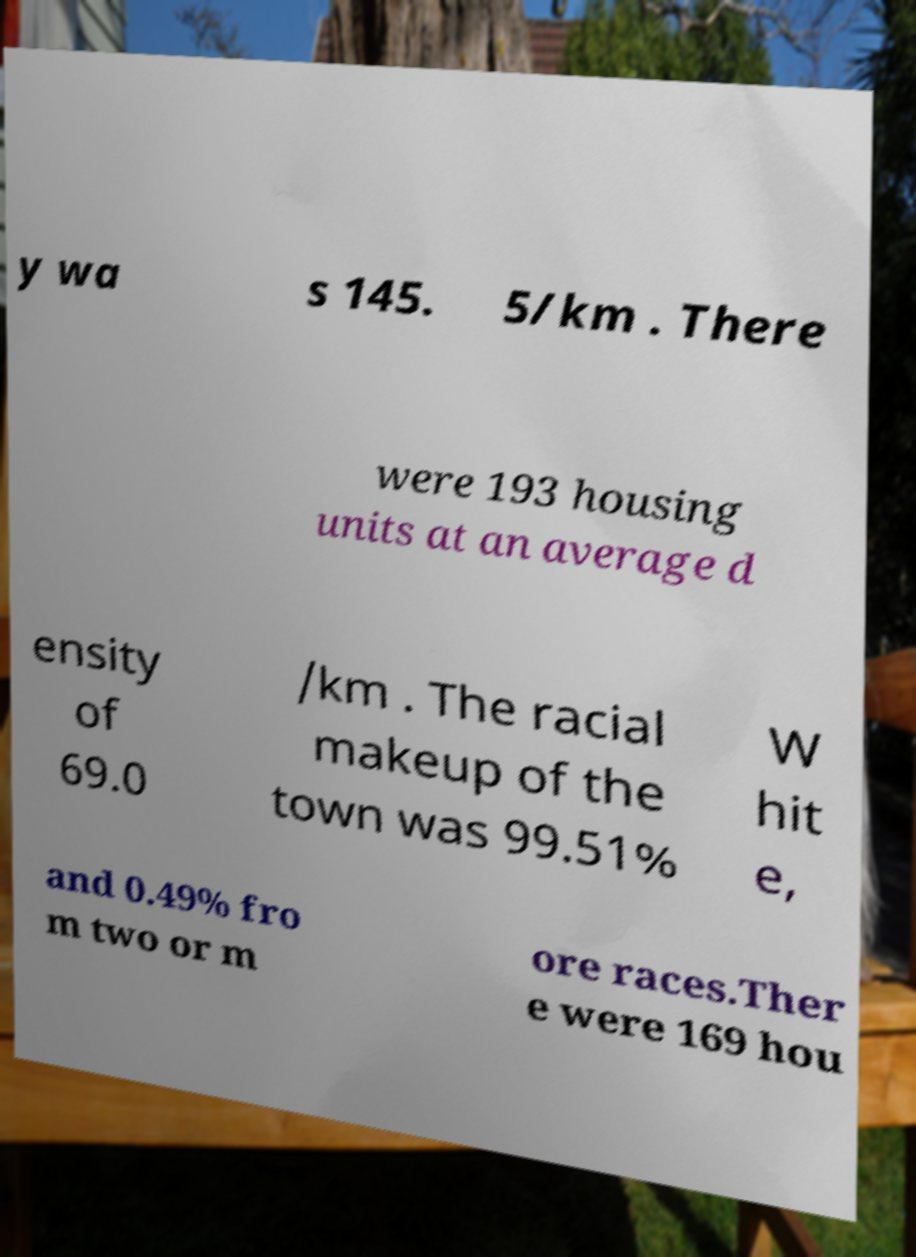Could you extract and type out the text from this image? y wa s 145. 5/km . There were 193 housing units at an average d ensity of 69.0 /km . The racial makeup of the town was 99.51% W hit e, and 0.49% fro m two or m ore races.Ther e were 169 hou 